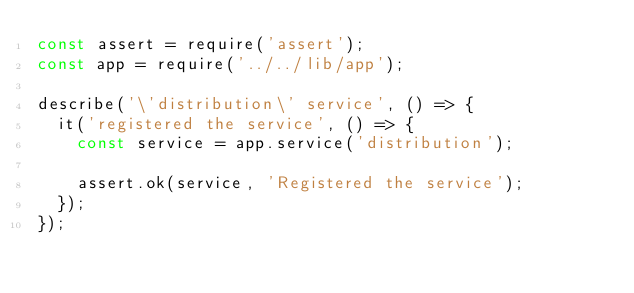<code> <loc_0><loc_0><loc_500><loc_500><_JavaScript_>const assert = require('assert');
const app = require('../../lib/app');

describe('\'distribution\' service', () => {
  it('registered the service', () => {
    const service = app.service('distribution');

    assert.ok(service, 'Registered the service');
  });
});
</code> 